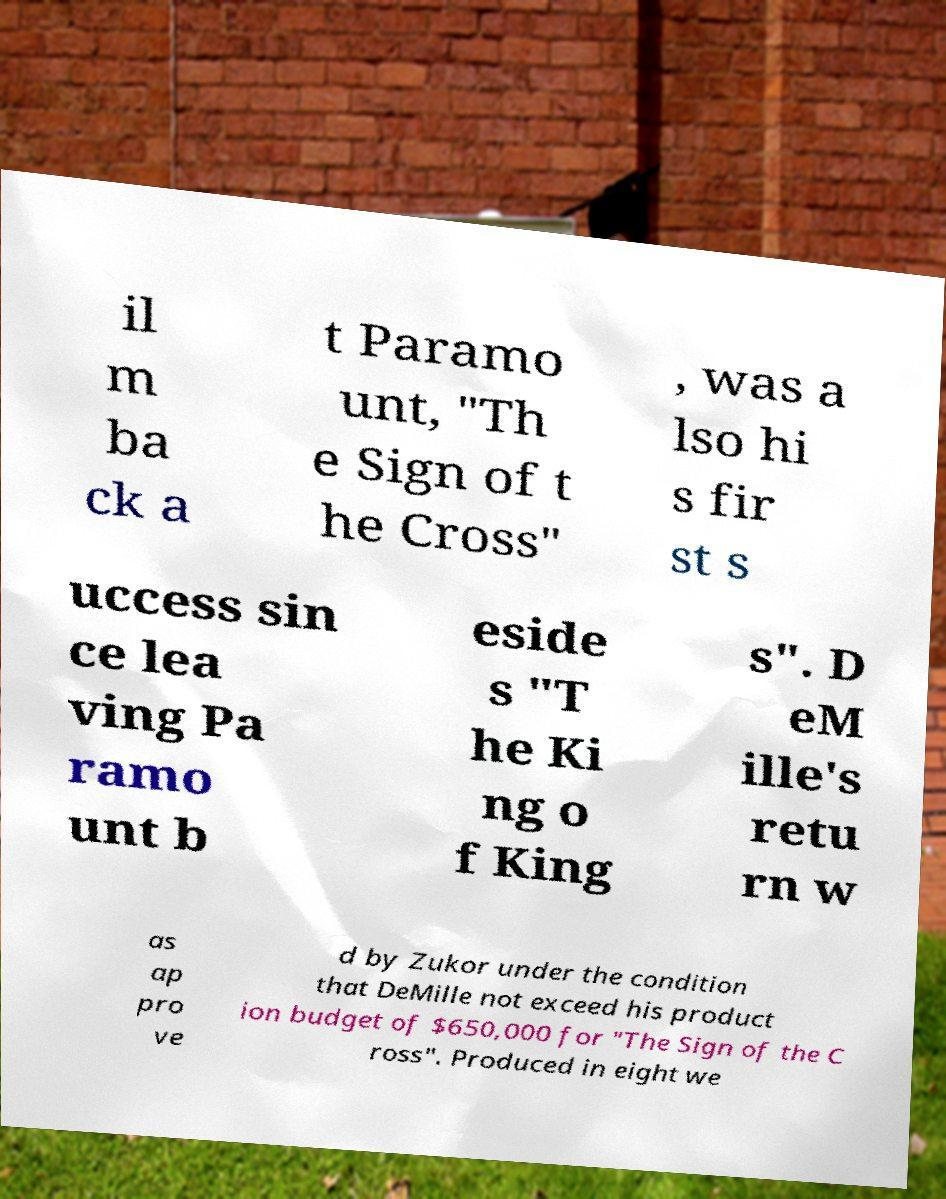For documentation purposes, I need the text within this image transcribed. Could you provide that? il m ba ck a t Paramo unt, "Th e Sign of t he Cross" , was a lso hi s fir st s uccess sin ce lea ving Pa ramo unt b eside s "T he Ki ng o f King s". D eM ille's retu rn w as ap pro ve d by Zukor under the condition that DeMille not exceed his product ion budget of $650,000 for "The Sign of the C ross". Produced in eight we 